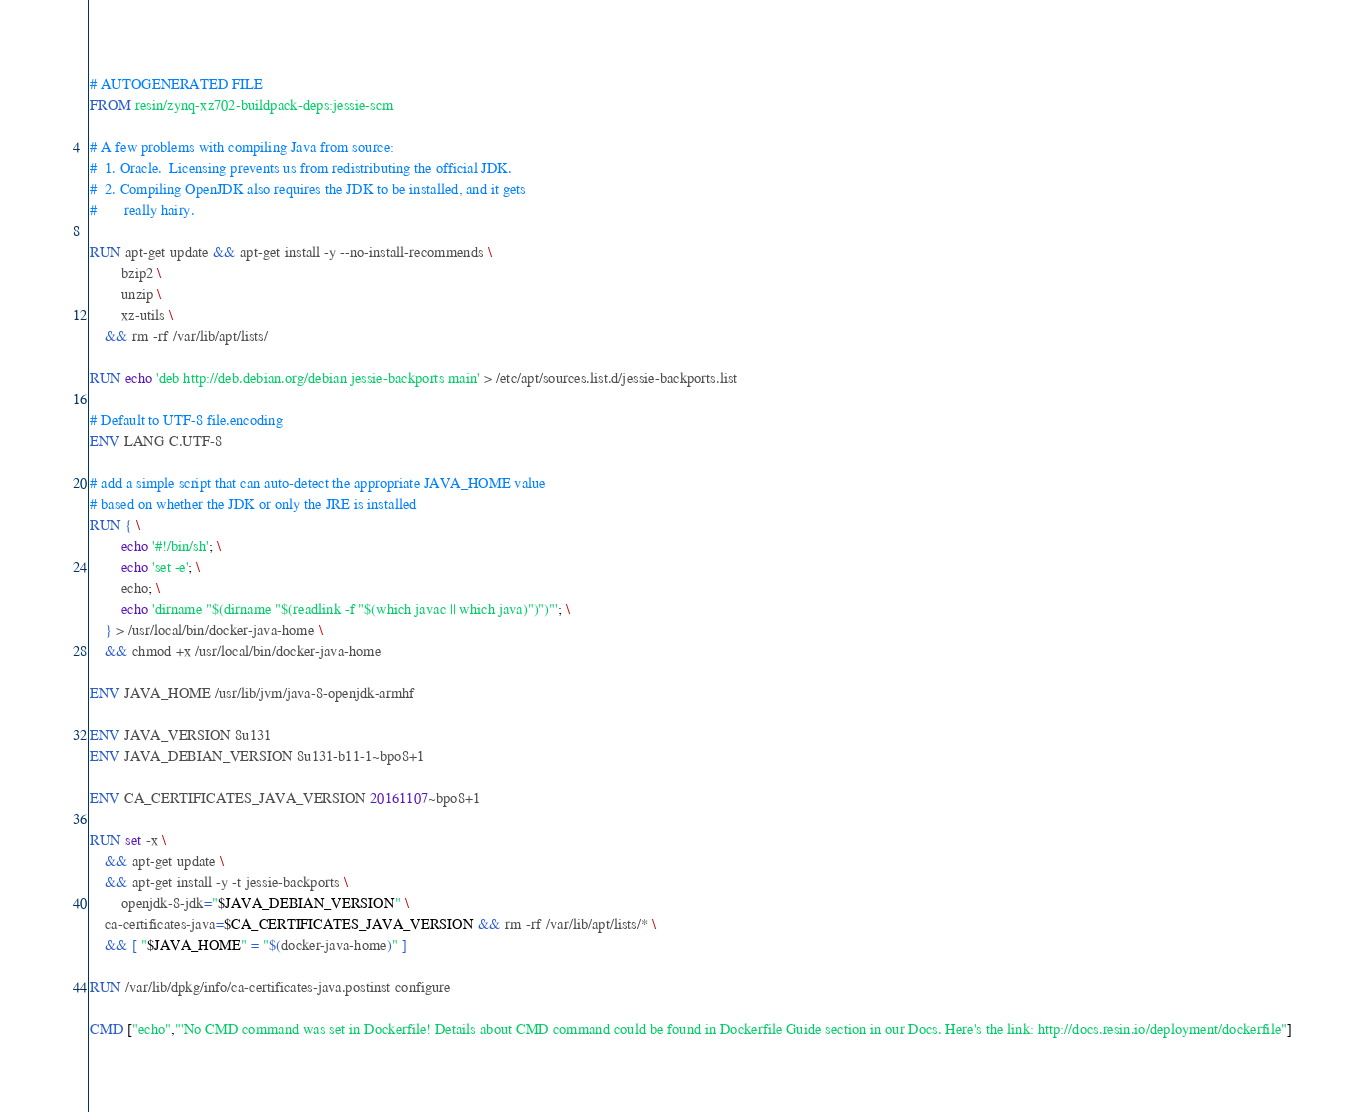<code> <loc_0><loc_0><loc_500><loc_500><_Dockerfile_># AUTOGENERATED FILE
FROM resin/zynq-xz702-buildpack-deps:jessie-scm

# A few problems with compiling Java from source:
#  1. Oracle.  Licensing prevents us from redistributing the official JDK.
#  2. Compiling OpenJDK also requires the JDK to be installed, and it gets
#       really hairy.

RUN apt-get update && apt-get install -y --no-install-recommends \
		bzip2 \
		unzip \
		xz-utils \
	&& rm -rf /var/lib/apt/lists/

RUN echo 'deb http://deb.debian.org/debian jessie-backports main' > /etc/apt/sources.list.d/jessie-backports.list

# Default to UTF-8 file.encoding
ENV LANG C.UTF-8

# add a simple script that can auto-detect the appropriate JAVA_HOME value
# based on whether the JDK or only the JRE is installed
RUN { \
		echo '#!/bin/sh'; \
		echo 'set -e'; \
		echo; \
		echo 'dirname "$(dirname "$(readlink -f "$(which javac || which java)")")"'; \
	} > /usr/local/bin/docker-java-home \
	&& chmod +x /usr/local/bin/docker-java-home

ENV JAVA_HOME /usr/lib/jvm/java-8-openjdk-armhf

ENV JAVA_VERSION 8u131
ENV JAVA_DEBIAN_VERSION 8u131-b11-1~bpo8+1

ENV CA_CERTIFICATES_JAVA_VERSION 20161107~bpo8+1

RUN set -x \
	&& apt-get update \
	&& apt-get install -y -t jessie-backports \
		openjdk-8-jdk="$JAVA_DEBIAN_VERSION" \
	ca-certificates-java=$CA_CERTIFICATES_JAVA_VERSION && rm -rf /var/lib/apt/lists/* \
	&& [ "$JAVA_HOME" = "$(docker-java-home)" ]

RUN /var/lib/dpkg/info/ca-certificates-java.postinst configure

CMD ["echo","'No CMD command was set in Dockerfile! Details about CMD command could be found in Dockerfile Guide section in our Docs. Here's the link: http://docs.resin.io/deployment/dockerfile"]
</code> 